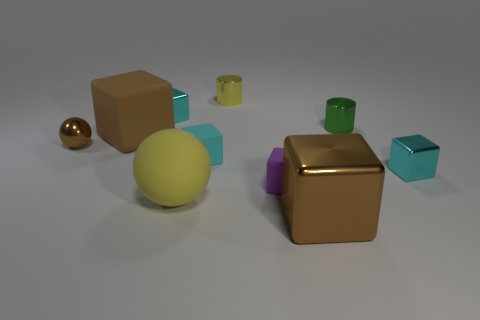Are there fewer large rubber blocks behind the large brown matte block than big brown objects in front of the tiny brown sphere?
Provide a short and direct response. Yes. Are there any brown things of the same shape as the purple matte object?
Offer a terse response. Yes. Does the small brown thing have the same shape as the small purple thing?
Provide a succinct answer. No. How many big things are blue cylinders or shiny cubes?
Provide a succinct answer. 1. Are there more small brown objects than blocks?
Offer a terse response. No. What size is the brown block that is made of the same material as the yellow ball?
Provide a short and direct response. Large. There is a block that is behind the big rubber block; does it have the same size as the metal thing that is in front of the large yellow matte object?
Your answer should be very brief. No. What number of things are either tiny things that are behind the tiny cyan matte block or small yellow cylinders?
Provide a short and direct response. 4. Is the number of cyan blocks less than the number of small cubes?
Provide a succinct answer. Yes. What is the shape of the yellow object that is behind the big brown cube that is behind the tiny cyan block on the right side of the small green metal cylinder?
Your answer should be compact. Cylinder. 